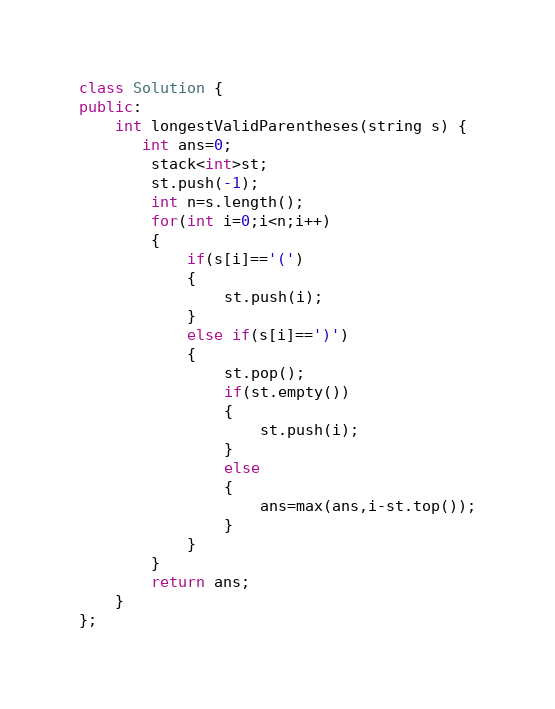Convert code to text. <code><loc_0><loc_0><loc_500><loc_500><_C++_>class Solution {
public:
    int longestValidParentheses(string s) {
       int ans=0;
        stack<int>st;
        st.push(-1);
        int n=s.length();
        for(int i=0;i<n;i++)
        {
            if(s[i]=='(')
            {
                st.push(i);
            }
            else if(s[i]==')')
            {
                st.pop();
                if(st.empty())
                {
                    st.push(i);
                }
                else
                {
                    ans=max(ans,i-st.top());
                }
            }
        }
        return ans;
    }
};</code> 